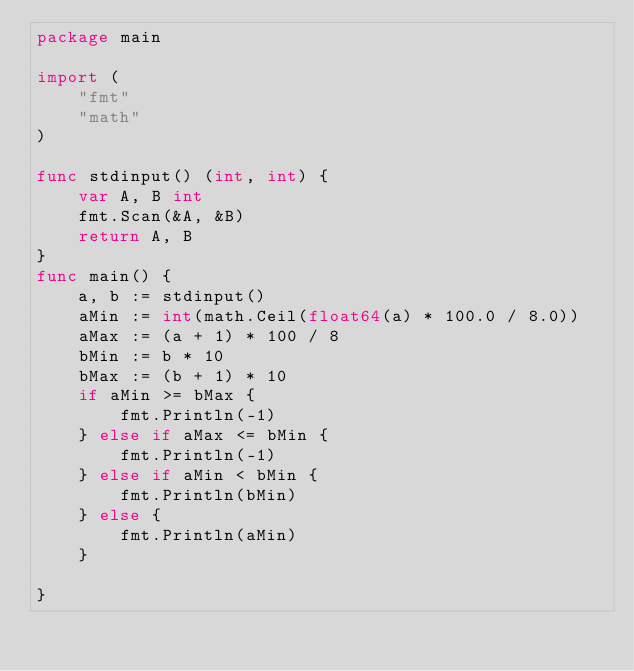<code> <loc_0><loc_0><loc_500><loc_500><_Go_>package main

import (
	"fmt"
	"math"
)

func stdinput() (int, int) {
	var A, B int
	fmt.Scan(&A, &B)
	return A, B
}
func main() {
	a, b := stdinput()
	aMin := int(math.Ceil(float64(a) * 100.0 / 8.0))
	aMax := (a + 1) * 100 / 8
	bMin := b * 10
	bMax := (b + 1) * 10
	if aMin >= bMax {
		fmt.Println(-1)
	} else if aMax <= bMin {
		fmt.Println(-1)
	} else if aMin < bMin {
		fmt.Println(bMin)
	} else {
		fmt.Println(aMin)
	}

}</code> 